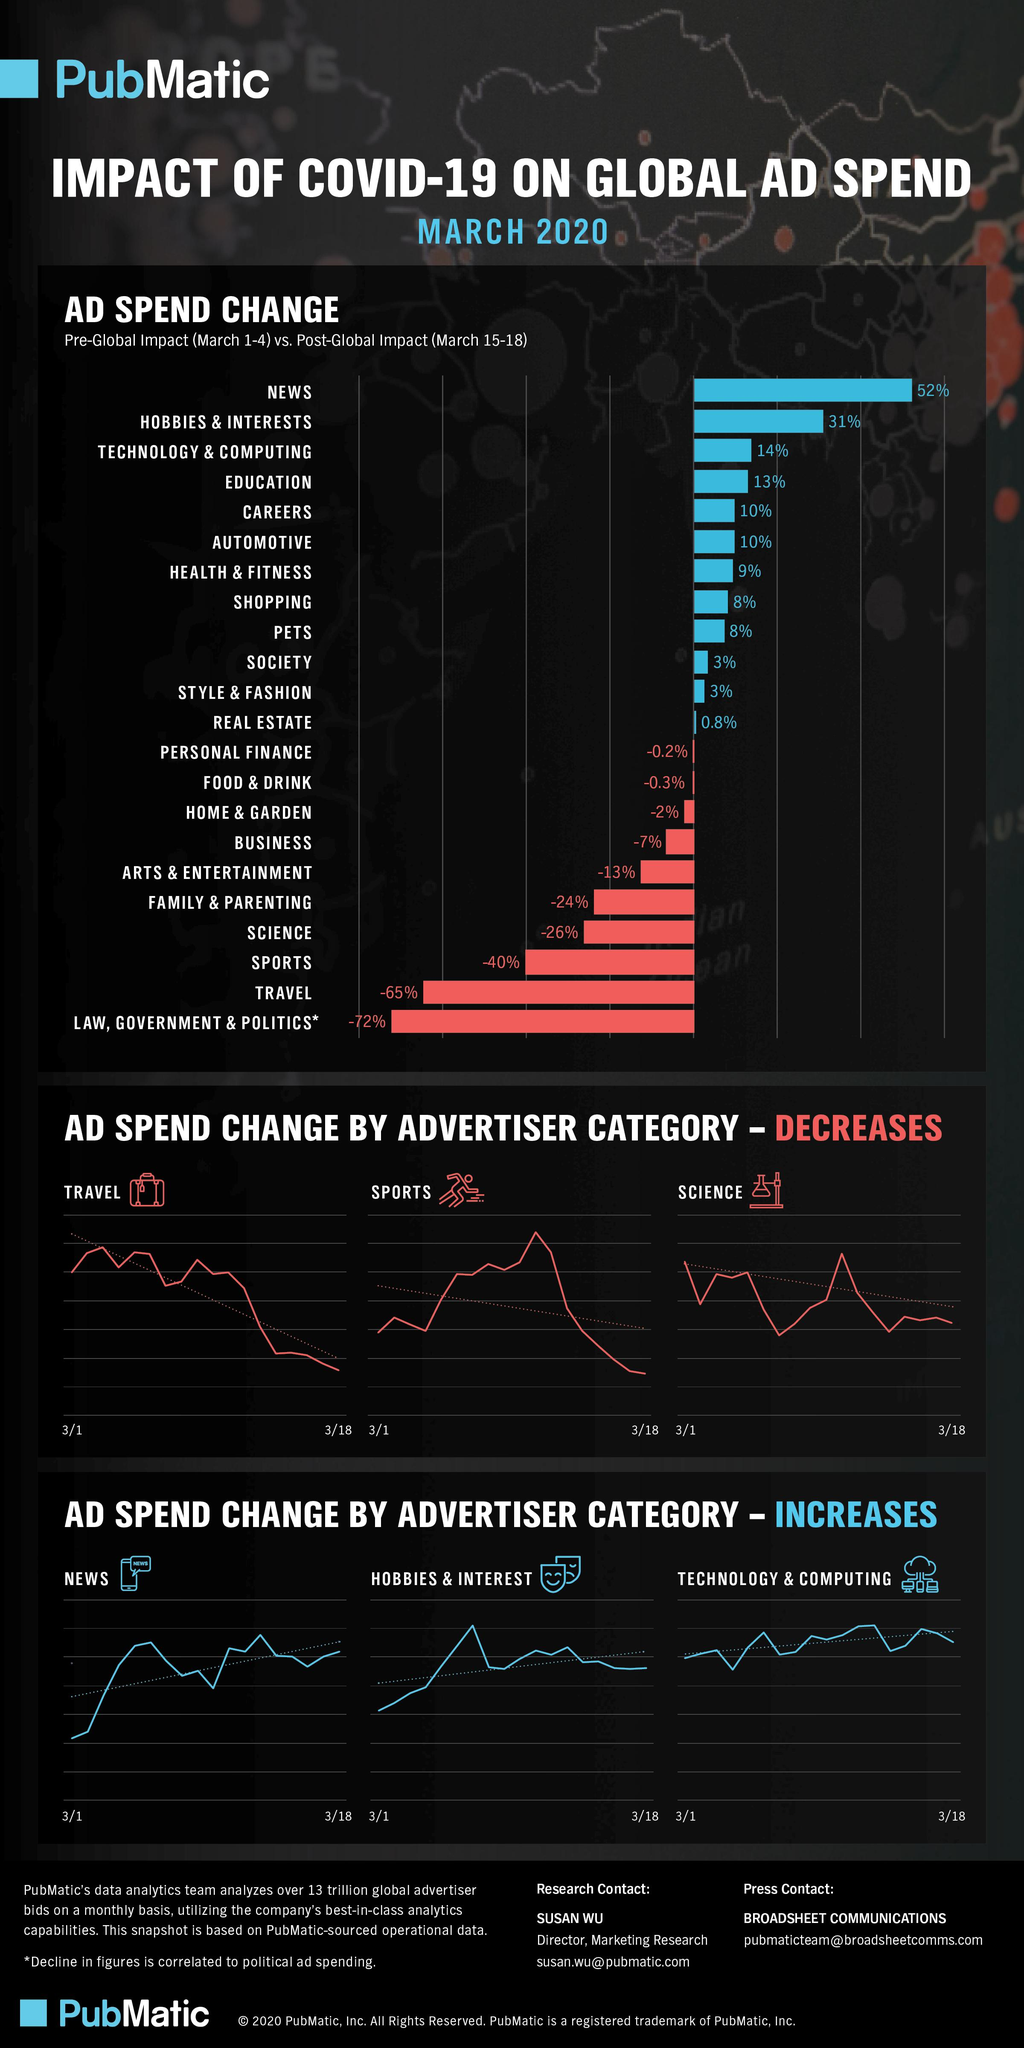List a handful of essential elements in this visual. The second category where the advertiser's ad spend has increased is hobbies & interests. The third highest percentage increase in ad spend is in the technology and computing sector, as evident from the bar graph. The bar graph displays four sectors where the ad spend has decreased by 25% or more. The bar graph shows that the travel sector has the second highest percentage reduction in ad spend. Of the sectors analyzed, two showed an increase of 25% or above in advertising spending. 